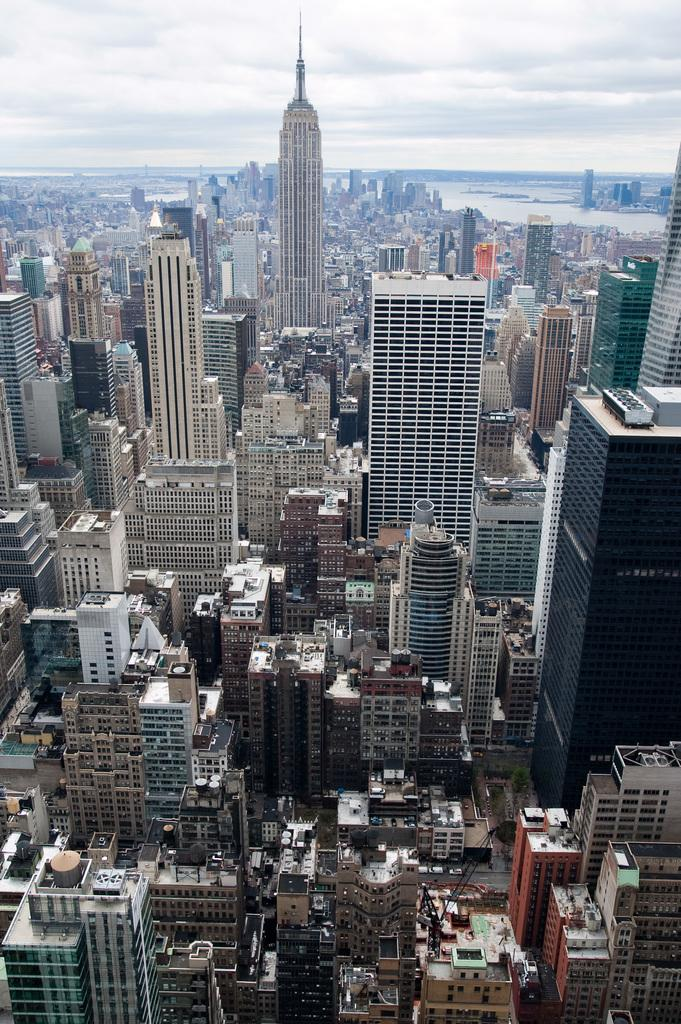What type of structures can be seen in the image? There are buildings in the image. What is visible at the top of the image? The sky is visible at the top of the image. How much honey is being produced by the buildings in the image? There is no honey production mentioned or depicted in the image, as it features buildings and the sky. 